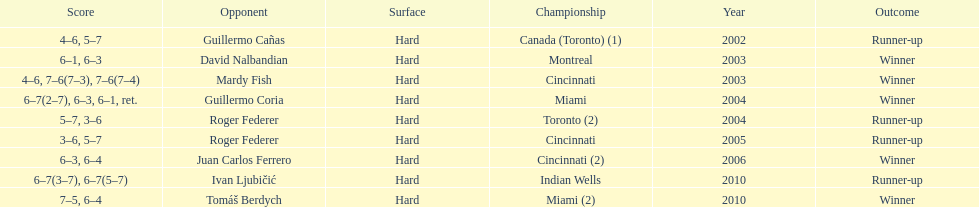How many times has he been runner-up? 4. 